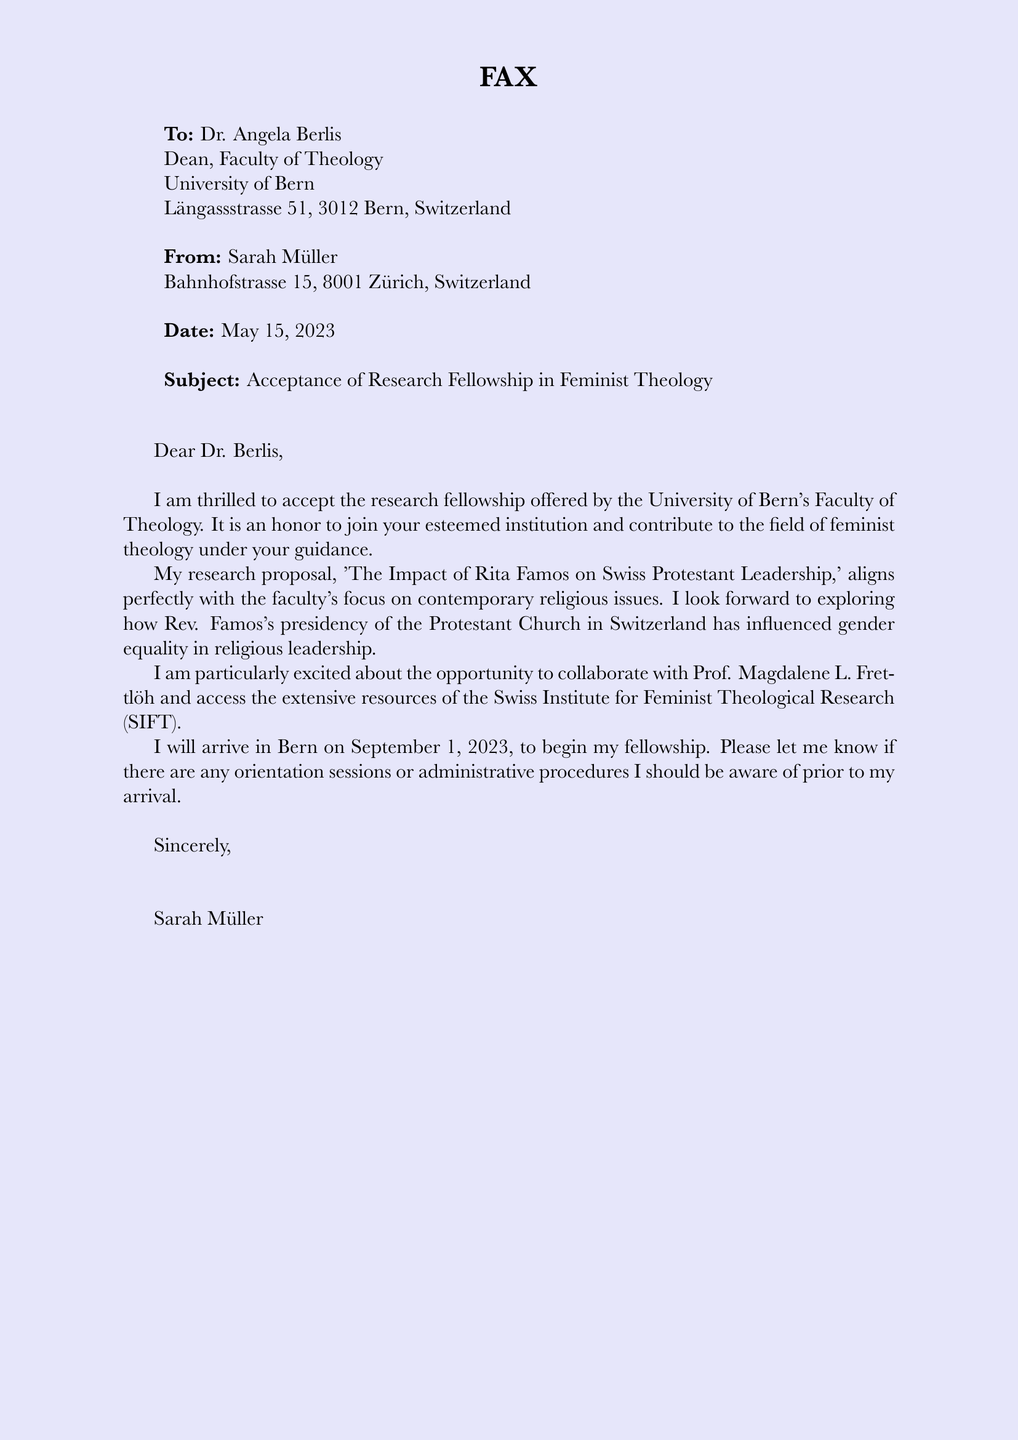What is the name of the recipient? The recipient's name is stated in the address section, which is Dr. Angela Berlis.
Answer: Dr. Angela Berlis What is the subject of the fax? The subject line of the fax clearly indicates the purpose of the message: acceptance of a fellowship.
Answer: Acceptance of Research Fellowship in Feminist Theology What is the sender's address? The sender's address is included in the heading, specifically at Bahnhofstrasse 15, 8001 Zürich, Switzerland.
Answer: Bahnhofstrasse 15, 8001 Zürich, Switzerland On what date was the fax sent? The date is mentioned prominently in the document, indicating when the fax was sent.
Answer: May 15, 2023 What is the research proposal title? The title of the research proposal is included in the text of the letter.
Answer: The Impact of Rita Famos on Swiss Protestant Leadership Who is the sender of the fax? The sender's name is provided in the address section and sign-off of the document.
Answer: Sarah Müller When does the sender plan to arrive in Bern? The date of arrival is mentioned explicitly in the letter.
Answer: September 1, 2023 What is the name of the faculty where the sender received the fellowship? The name of the faculty is referenced in the introduction of the document.
Answer: Faculty of Theology What institution is the sender joining? The sender refers to the institution she is joining in the opening paragraph of the letter.
Answer: University of Bern Name one person the sender is excited to collaborate with. The sender mentions a specific professor she is looking forward to collaborating with in her letter.
Answer: Prof. Magdalene L. Frettlöh 